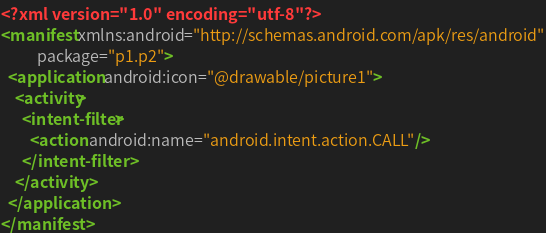<code> <loc_0><loc_0><loc_500><loc_500><_XML_><?xml version="1.0" encoding="utf-8"?>
<manifest xmlns:android="http://schemas.android.com/apk/res/android"
          package="p1.p2">
  <application android:icon="@drawable/picture1">
    <activity>
      <intent-filter>
        <action android:name="android.intent.action.CALL"/>
      </intent-filter>
    </activity>
  </application>
</manifest>
</code> 